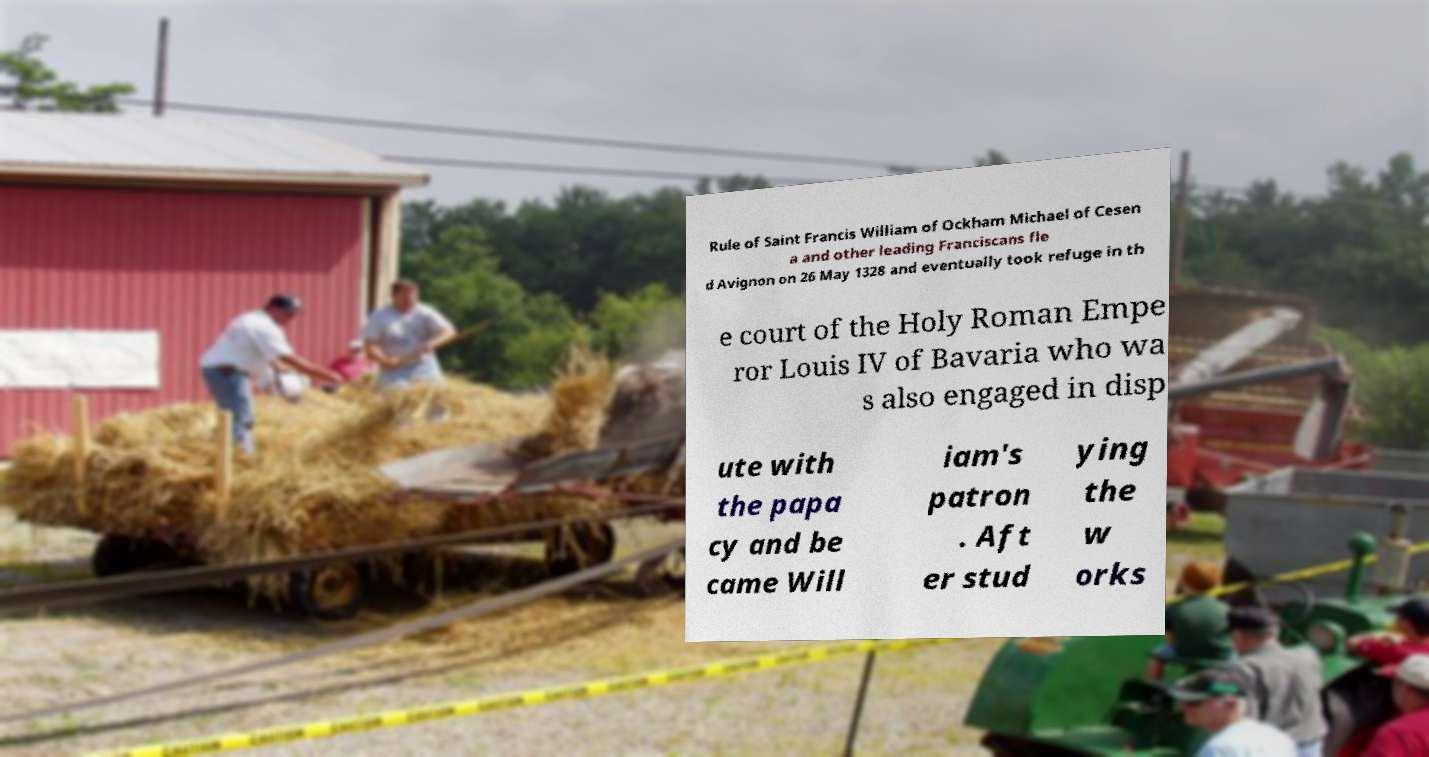Can you read and provide the text displayed in the image?This photo seems to have some interesting text. Can you extract and type it out for me? Rule of Saint Francis William of Ockham Michael of Cesen a and other leading Franciscans fle d Avignon on 26 May 1328 and eventually took refuge in th e court of the Holy Roman Empe ror Louis IV of Bavaria who wa s also engaged in disp ute with the papa cy and be came Will iam's patron . Aft er stud ying the w orks 